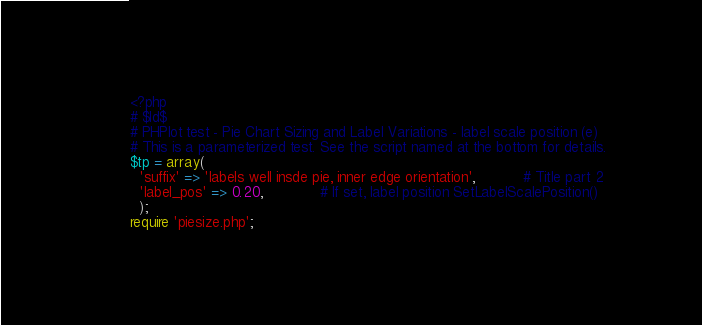Convert code to text. <code><loc_0><loc_0><loc_500><loc_500><_PHP_><?php
# $Id$
# PHPlot test - Pie Chart Sizing and Label Variations - label scale position (e)
# This is a parameterized test. See the script named at the bottom for details.
$tp = array(
  'suffix' => 'labels well insde pie, inner edge orientation',           # Title part 2
  'label_pos' => 0.20,             # If set, label position SetLabelScalePosition()
  );
require 'piesize.php';
</code> 